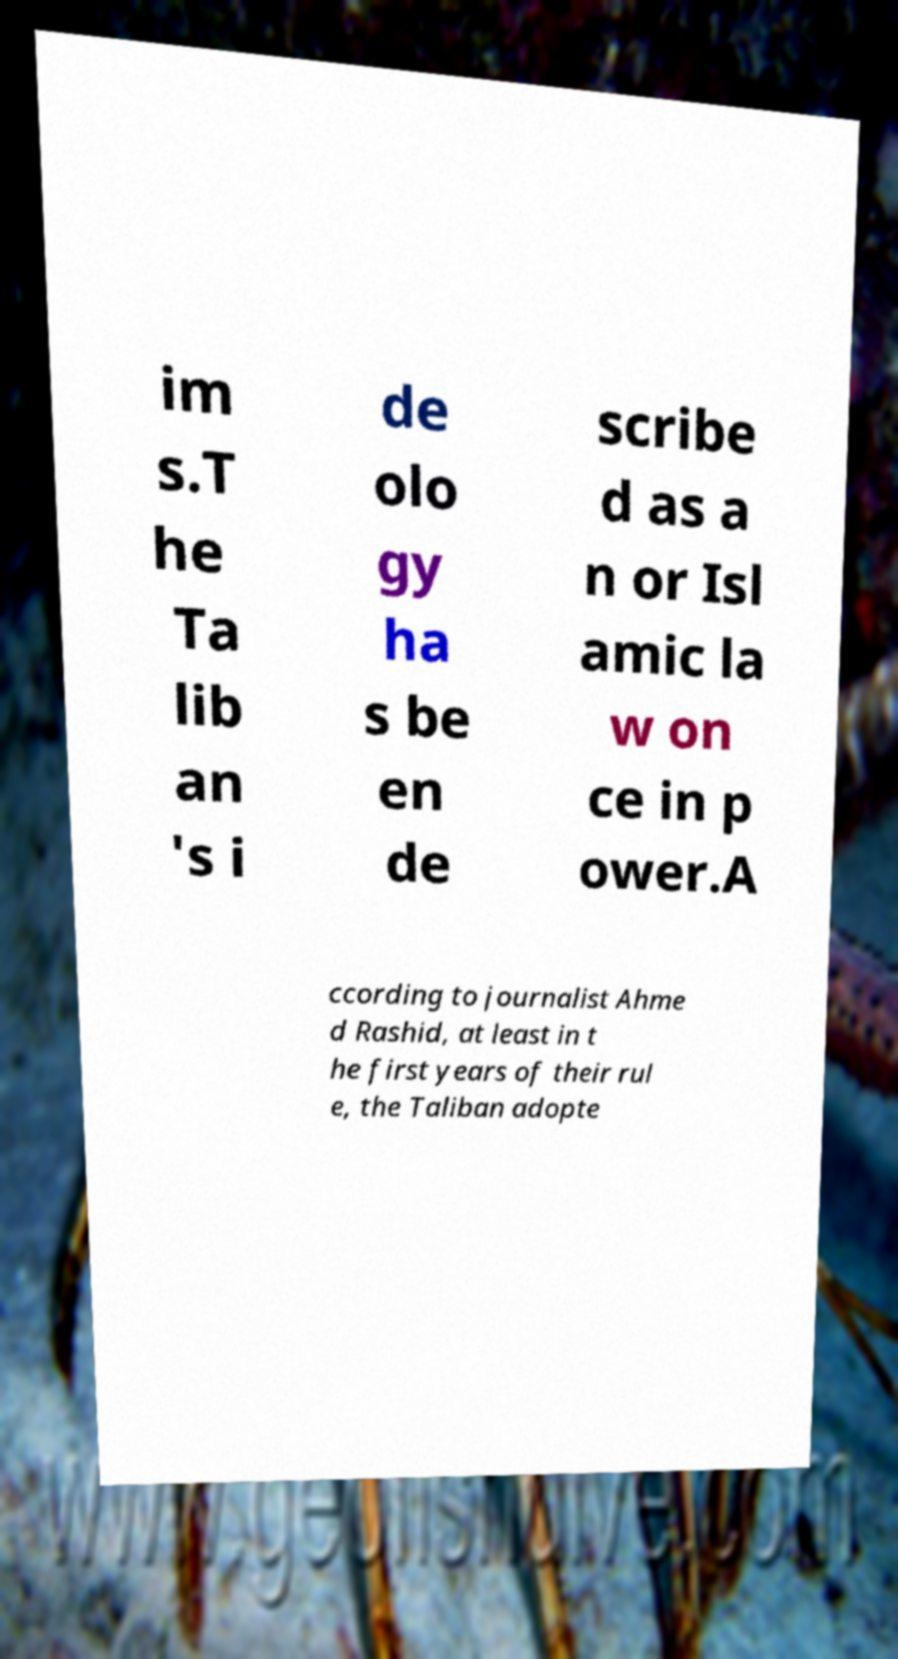Could you extract and type out the text from this image? im s.T he Ta lib an 's i de olo gy ha s be en de scribe d as a n or Isl amic la w on ce in p ower.A ccording to journalist Ahme d Rashid, at least in t he first years of their rul e, the Taliban adopte 